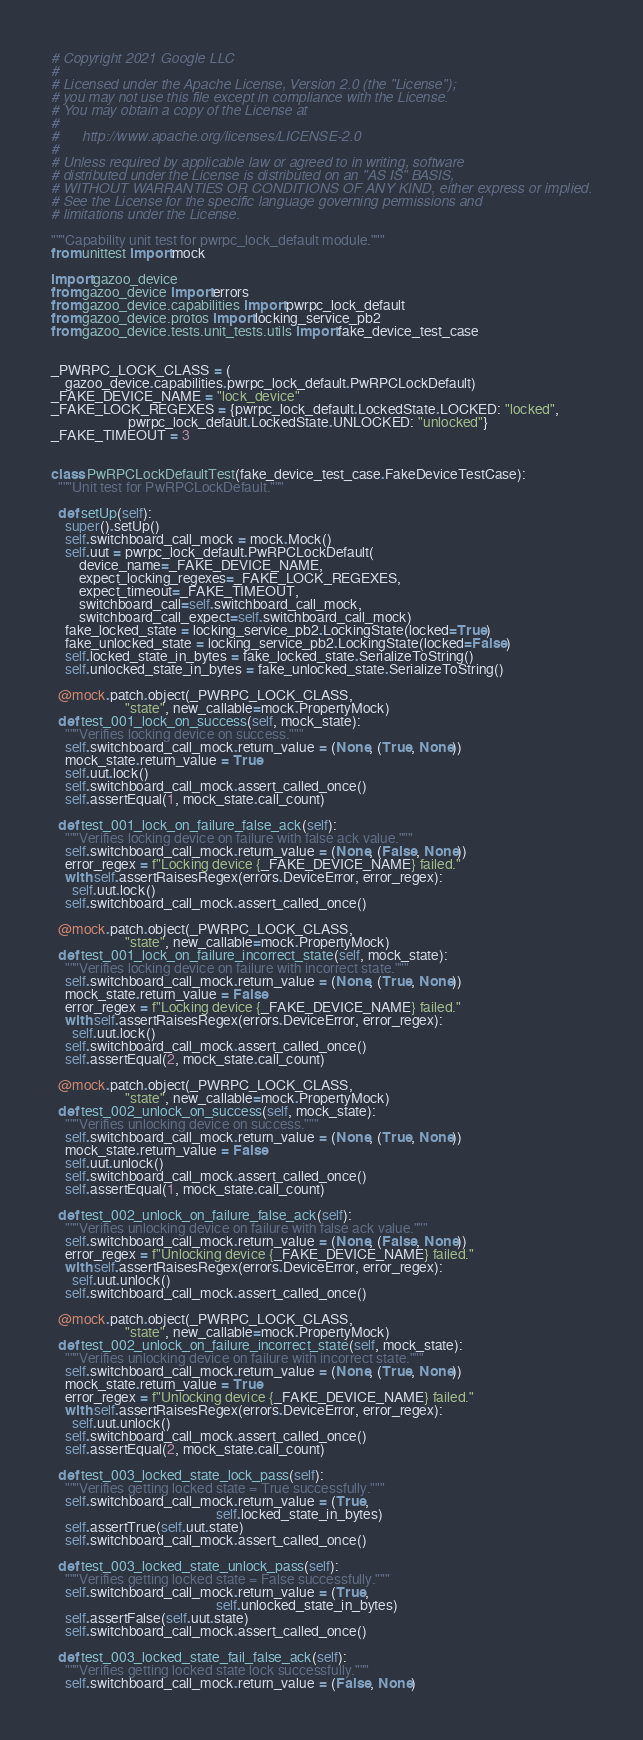Convert code to text. <code><loc_0><loc_0><loc_500><loc_500><_Python_># Copyright 2021 Google LLC
#
# Licensed under the Apache License, Version 2.0 (the "License");
# you may not use this file except in compliance with the License.
# You may obtain a copy of the License at
#
#      http://www.apache.org/licenses/LICENSE-2.0
#
# Unless required by applicable law or agreed to in writing, software
# distributed under the License is distributed on an "AS IS" BASIS,
# WITHOUT WARRANTIES OR CONDITIONS OF ANY KIND, either express or implied.
# See the License for the specific language governing permissions and
# limitations under the License.

"""Capability unit test for pwrpc_lock_default module."""
from unittest import mock

import gazoo_device
from gazoo_device import errors
from gazoo_device.capabilities import pwrpc_lock_default
from gazoo_device.protos import locking_service_pb2
from gazoo_device.tests.unit_tests.utils import fake_device_test_case


_PWRPC_LOCK_CLASS = (
    gazoo_device.capabilities.pwrpc_lock_default.PwRPCLockDefault)
_FAKE_DEVICE_NAME = "lock_device"
_FAKE_LOCK_REGEXES = {pwrpc_lock_default.LockedState.LOCKED: "locked",
                      pwrpc_lock_default.LockedState.UNLOCKED: "unlocked"}
_FAKE_TIMEOUT = 3


class PwRPCLockDefaultTest(fake_device_test_case.FakeDeviceTestCase):
  """Unit test for PwRPCLockDefault."""

  def setUp(self):
    super().setUp()
    self.switchboard_call_mock = mock.Mock()
    self.uut = pwrpc_lock_default.PwRPCLockDefault(
        device_name=_FAKE_DEVICE_NAME,
        expect_locking_regexes=_FAKE_LOCK_REGEXES,
        expect_timeout=_FAKE_TIMEOUT,
        switchboard_call=self.switchboard_call_mock,
        switchboard_call_expect=self.switchboard_call_mock)
    fake_locked_state = locking_service_pb2.LockingState(locked=True)
    fake_unlocked_state = locking_service_pb2.LockingState(locked=False)
    self.locked_state_in_bytes = fake_locked_state.SerializeToString()
    self.unlocked_state_in_bytes = fake_unlocked_state.SerializeToString()

  @mock.patch.object(_PWRPC_LOCK_CLASS,
                     "state", new_callable=mock.PropertyMock)
  def test_001_lock_on_success(self, mock_state):
    """Verifies locking device on success."""
    self.switchboard_call_mock.return_value = (None, (True, None))
    mock_state.return_value = True
    self.uut.lock()
    self.switchboard_call_mock.assert_called_once()
    self.assertEqual(1, mock_state.call_count)

  def test_001_lock_on_failure_false_ack(self):
    """Verifies locking device on failure with false ack value."""
    self.switchboard_call_mock.return_value = (None, (False, None))
    error_regex = f"Locking device {_FAKE_DEVICE_NAME} failed."
    with self.assertRaisesRegex(errors.DeviceError, error_regex):
      self.uut.lock()
    self.switchboard_call_mock.assert_called_once()

  @mock.patch.object(_PWRPC_LOCK_CLASS,
                     "state", new_callable=mock.PropertyMock)
  def test_001_lock_on_failure_incorrect_state(self, mock_state):
    """Verifies locking device on failure with incorrect state."""
    self.switchboard_call_mock.return_value = (None, (True, None))
    mock_state.return_value = False
    error_regex = f"Locking device {_FAKE_DEVICE_NAME} failed."
    with self.assertRaisesRegex(errors.DeviceError, error_regex):
      self.uut.lock()
    self.switchboard_call_mock.assert_called_once()
    self.assertEqual(2, mock_state.call_count)

  @mock.patch.object(_PWRPC_LOCK_CLASS,
                     "state", new_callable=mock.PropertyMock)
  def test_002_unlock_on_success(self, mock_state):
    """Verifies unlocking device on success."""
    self.switchboard_call_mock.return_value = (None, (True, None))
    mock_state.return_value = False
    self.uut.unlock()
    self.switchboard_call_mock.assert_called_once()
    self.assertEqual(1, mock_state.call_count)

  def test_002_unlock_on_failure_false_ack(self):
    """Verifies unlocking device on failure with false ack value."""
    self.switchboard_call_mock.return_value = (None, (False, None))
    error_regex = f"Unlocking device {_FAKE_DEVICE_NAME} failed."
    with self.assertRaisesRegex(errors.DeviceError, error_regex):
      self.uut.unlock()
    self.switchboard_call_mock.assert_called_once()

  @mock.patch.object(_PWRPC_LOCK_CLASS,
                     "state", new_callable=mock.PropertyMock)
  def test_002_unlock_on_failure_incorrect_state(self, mock_state):
    """Verifies unlocking device on failure with incorrect state."""
    self.switchboard_call_mock.return_value = (None, (True, None))
    mock_state.return_value = True
    error_regex = f"Unlocking device {_FAKE_DEVICE_NAME} failed."
    with self.assertRaisesRegex(errors.DeviceError, error_regex):
      self.uut.unlock()
    self.switchboard_call_mock.assert_called_once()
    self.assertEqual(2, mock_state.call_count)

  def test_003_locked_state_lock_pass(self):
    """Verifies getting locked state = True successfully."""
    self.switchboard_call_mock.return_value = (True,
                                               self.locked_state_in_bytes)
    self.assertTrue(self.uut.state)
    self.switchboard_call_mock.assert_called_once()

  def test_003_locked_state_unlock_pass(self):
    """Verifies getting locked state = False successfully."""
    self.switchboard_call_mock.return_value = (True,
                                               self.unlocked_state_in_bytes)
    self.assertFalse(self.uut.state)
    self.switchboard_call_mock.assert_called_once()

  def test_003_locked_state_fail_false_ack(self):
    """Verifies getting locked state lock successfully."""
    self.switchboard_call_mock.return_value = (False, None)</code> 